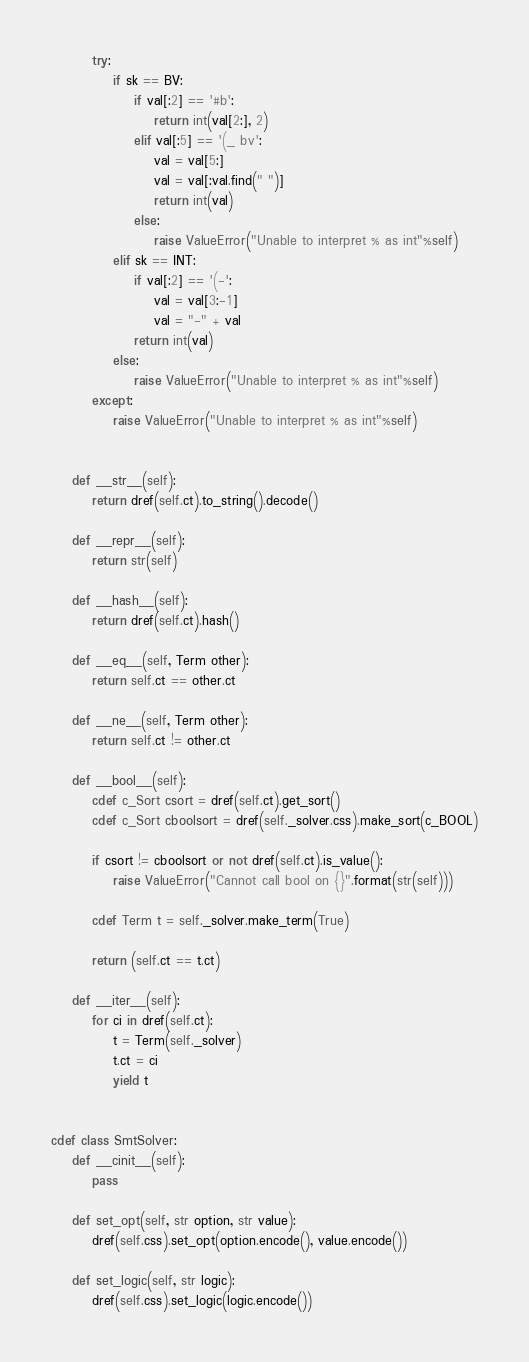Convert code to text. <code><loc_0><loc_0><loc_500><loc_500><_Cython_>        try:
            if sk == BV:
                if val[:2] == '#b':
                    return int(val[2:], 2)
                elif val[:5] == '(_ bv':
                    val = val[5:]
                    val = val[:val.find(" ")]
                    return int(val)
                else:
                    raise ValueError("Unable to interpret % as int"%self)
            elif sk == INT:
                if val[:2] == '(-':
                    val = val[3:-1]
                    val = "-" + val
                return int(val)
            else:
                raise ValueError("Unable to interpret % as int"%self)
        except:
            raise ValueError("Unable to interpret % as int"%self)


    def __str__(self):
        return dref(self.ct).to_string().decode()

    def __repr__(self):
        return str(self)

    def __hash__(self):
        return dref(self.ct).hash()

    def __eq__(self, Term other):
        return self.ct == other.ct

    def __ne__(self, Term other):
        return self.ct != other.ct

    def __bool__(self):
        cdef c_Sort csort = dref(self.ct).get_sort()
        cdef c_Sort cboolsort = dref(self._solver.css).make_sort(c_BOOL)

        if csort != cboolsort or not dref(self.ct).is_value():
            raise ValueError("Cannot call bool on {}".format(str(self)))

        cdef Term t = self._solver.make_term(True)

        return (self.ct == t.ct)

    def __iter__(self):
        for ci in dref(self.ct):
            t = Term(self._solver)
            t.ct = ci
            yield t


cdef class SmtSolver:
    def __cinit__(self):
        pass

    def set_opt(self, str option, str value):
        dref(self.css).set_opt(option.encode(), value.encode())

    def set_logic(self, str logic):
        dref(self.css).set_logic(logic.encode())
</code> 